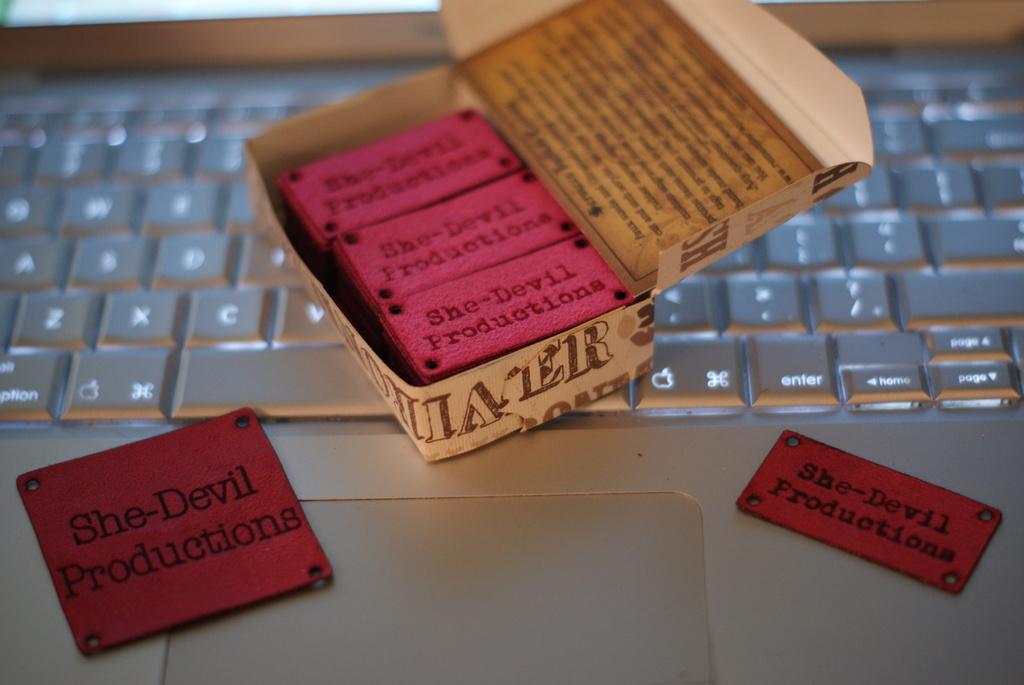What is the name of the production company?
Provide a short and direct response. She-devil productions. What color is the plates with "she-devil productions" on them?
Provide a short and direct response. Red. 